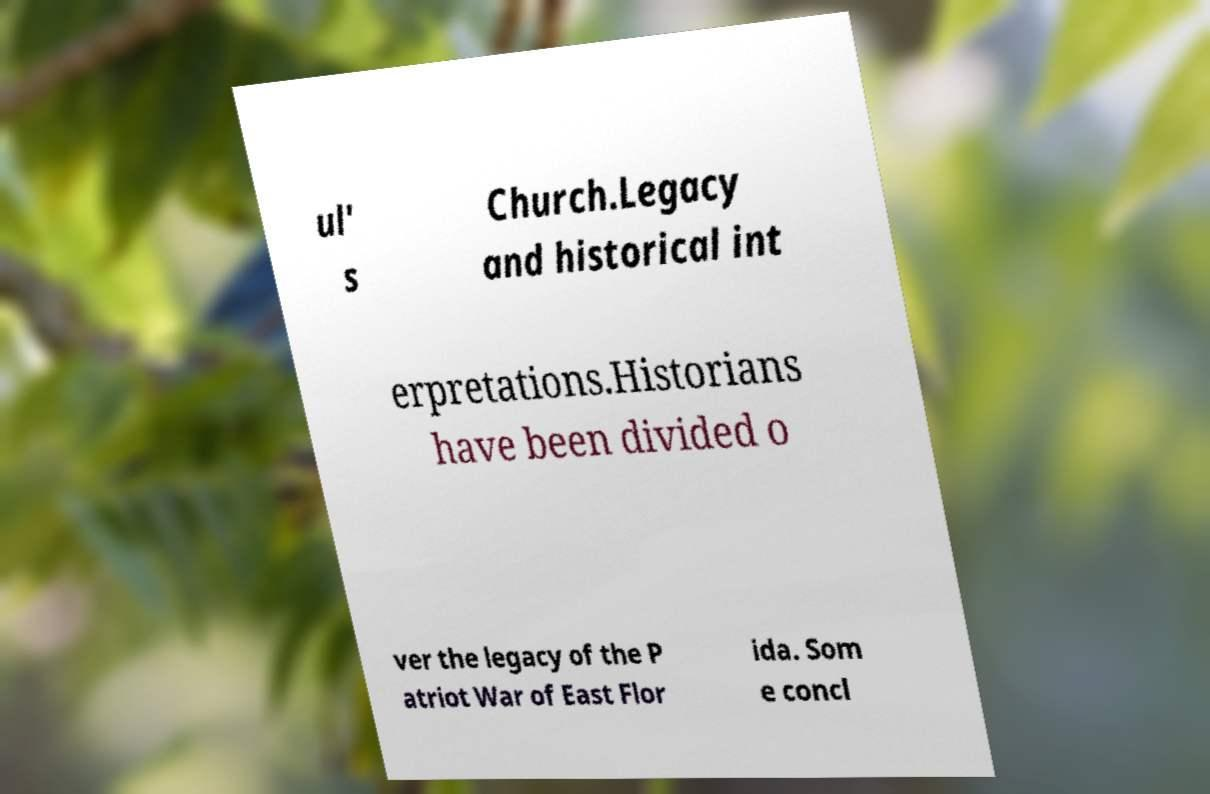Could you assist in decoding the text presented in this image and type it out clearly? ul' s Church.Legacy and historical int erpretations.Historians have been divided o ver the legacy of the P atriot War of East Flor ida. Som e concl 